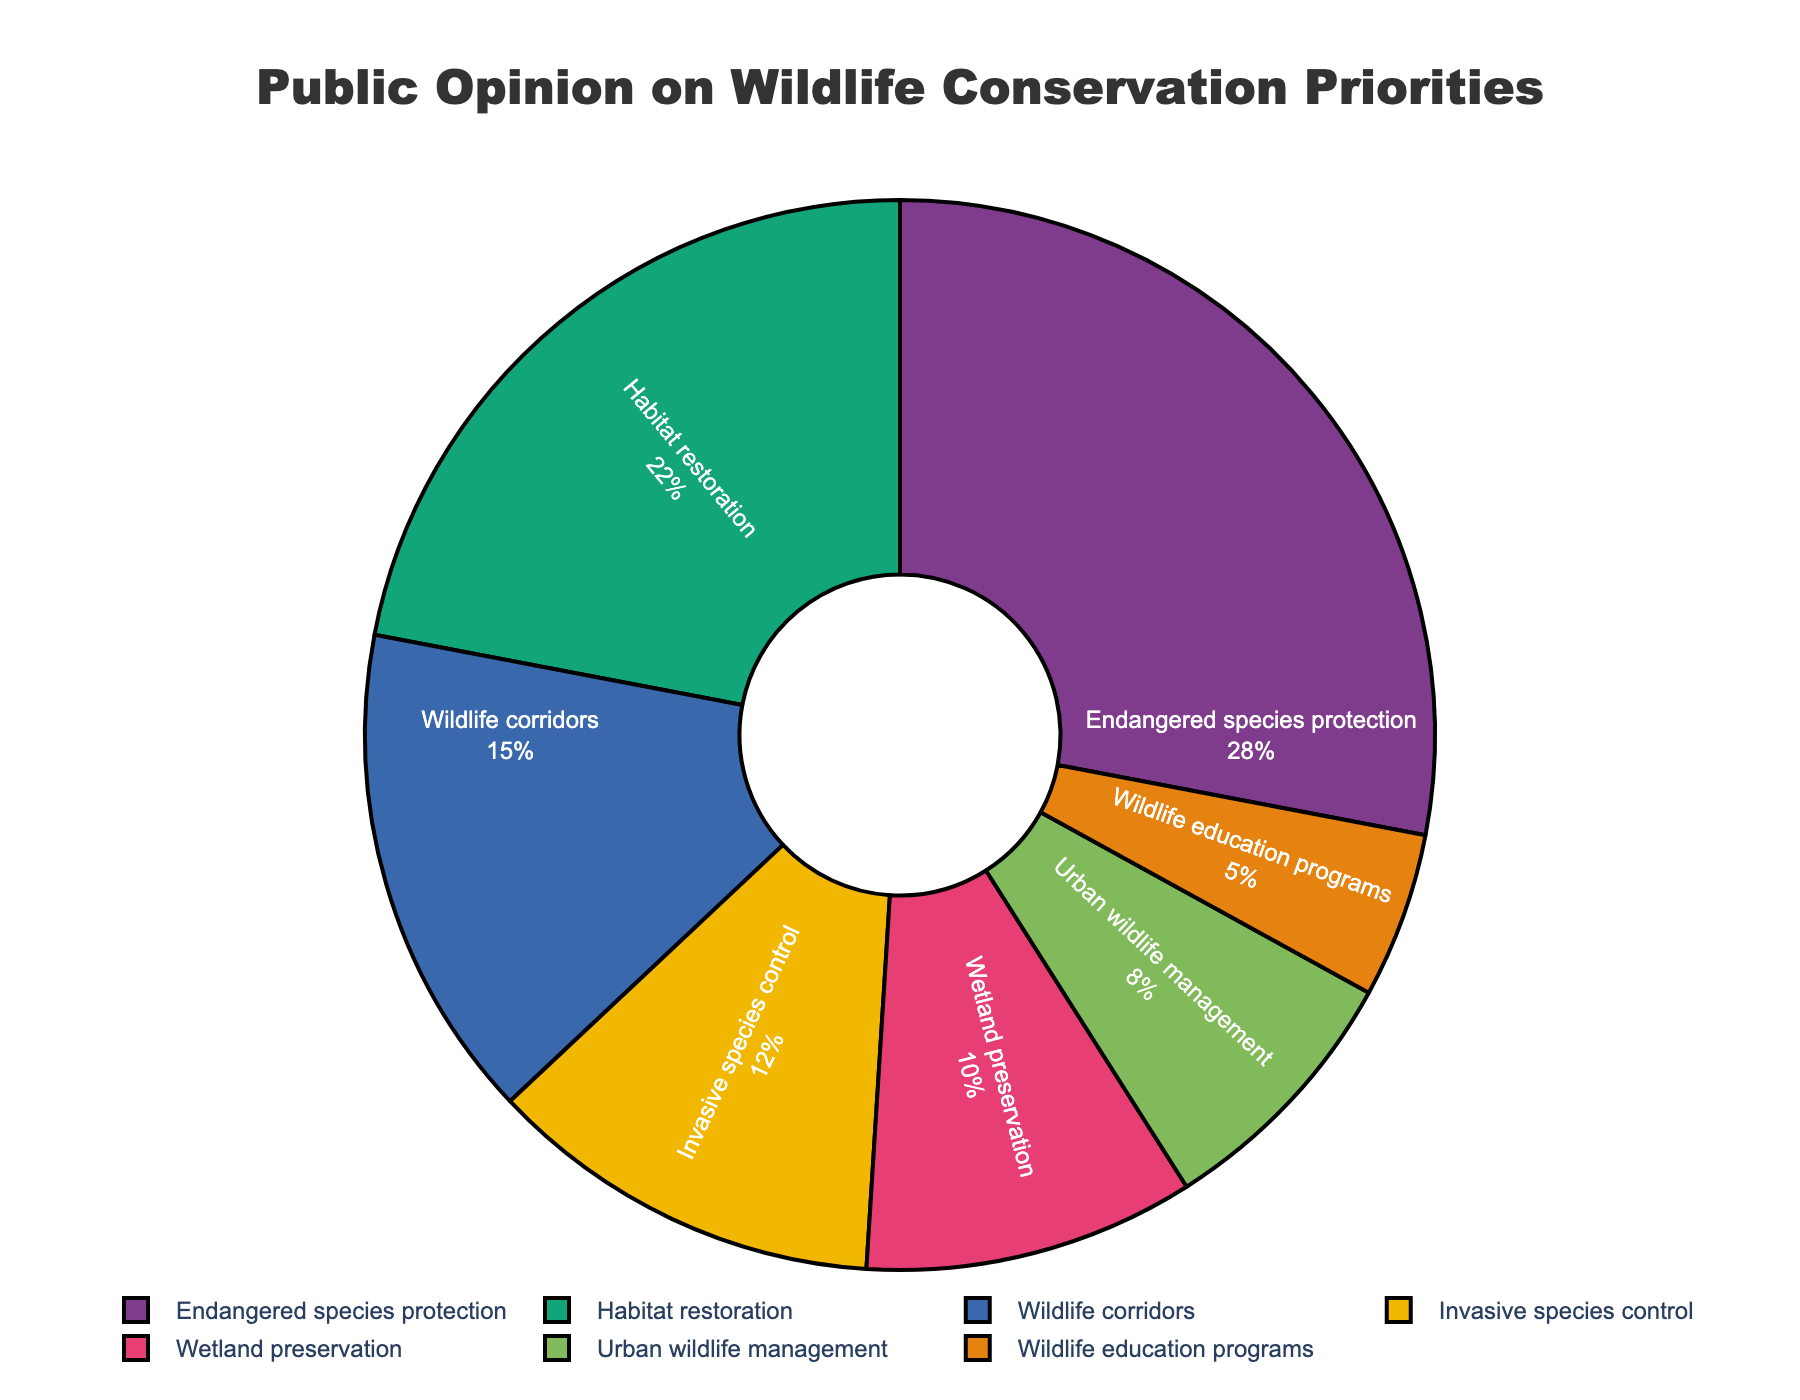What percentage of people prioritize endangered species protection? The slice labeled "Endangered species protection" shows a percentage directly inside the segment.
Answer: 28% Which category has the second-highest priority according to the public? By comparing the slice sizes and reading the percentage values inside the segments, we see that "Habitat restoration" is the second highest with 22%.
Answer: Habitat restoration Are there more people concerned with wildlife corridors or wetland preservation? We can compare the percentages of "Wildlife corridors" and "Wetland preservation". Wildlife corridors have 15%, and wetland preservation has 10%, so more people are concerned with wildlife corridors.
Answer: Wildlife corridors What is the combined percentage of people prioritizing habitat restoration and urban wildlife management? The slice for "Habitat restoration" is 22%, and "Urban wildlife management" is 8%. Summing these gives 22% + 8% = 30%.
Answer: 30% Which priorities are emphasized less than invasive species control? The percentages less than 12% are for "Wetland preservation," "Urban wildlife management," and "Wildlife education programs."
Answer: Wetland preservation, Urban wildlife management, Wildlife education programs How much more emphasis is there on habitat restoration compared to urban wildlife management? The slice for "Habitat restoration" is 22%, and "Urban wildlife management" is 8%. The difference is 22% - 8% = 14%.
Answer: 14% If we grouped wildlife corridors and invasive species control together, what would their total percentage be? The slice for "Wildlife corridors" is 15%, and "Invasive species control" is 12%. Their combined percentage is 15% + 12% = 27%.
Answer: 27% What percentage of people prioritize education programs for wildlife? The slice labeled "Wildlife education programs" shows the percentage directly inside the segment.
Answer: 5% Rank the categories from highest to lowest based on public opinion. By reading the percentage values inside the segments, we can order them as follows: Endangered species protection (28%), Habitat restoration (22%), Wildlife corridors (15%), Invasive species control (12%), Wetland preservation (10%), Urban wildlife management (8%), Wildlife education programs (5%).
Answer: Endangered species protection, Habitat restoration, Wildlife corridors, Invasive species control, Wetland preservation, Urban wildlife management, Wildlife education programs 